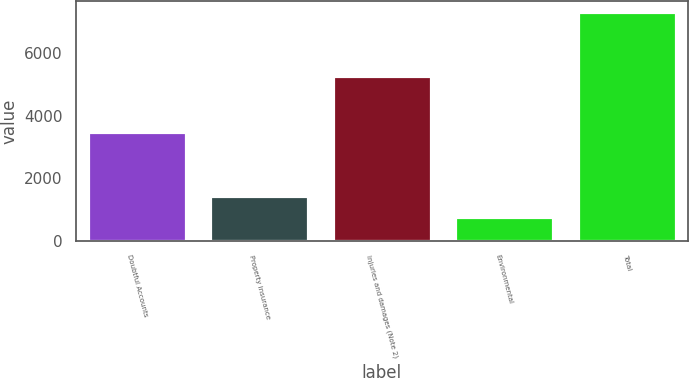Convert chart to OTSL. <chart><loc_0><loc_0><loc_500><loc_500><bar_chart><fcel>Doubtful Accounts<fcel>Property insurance<fcel>Injuries and damages (Note 2)<fcel>Environmental<fcel>Total<nl><fcel>3492<fcel>1419.2<fcel>5265<fcel>766<fcel>7298<nl></chart> 